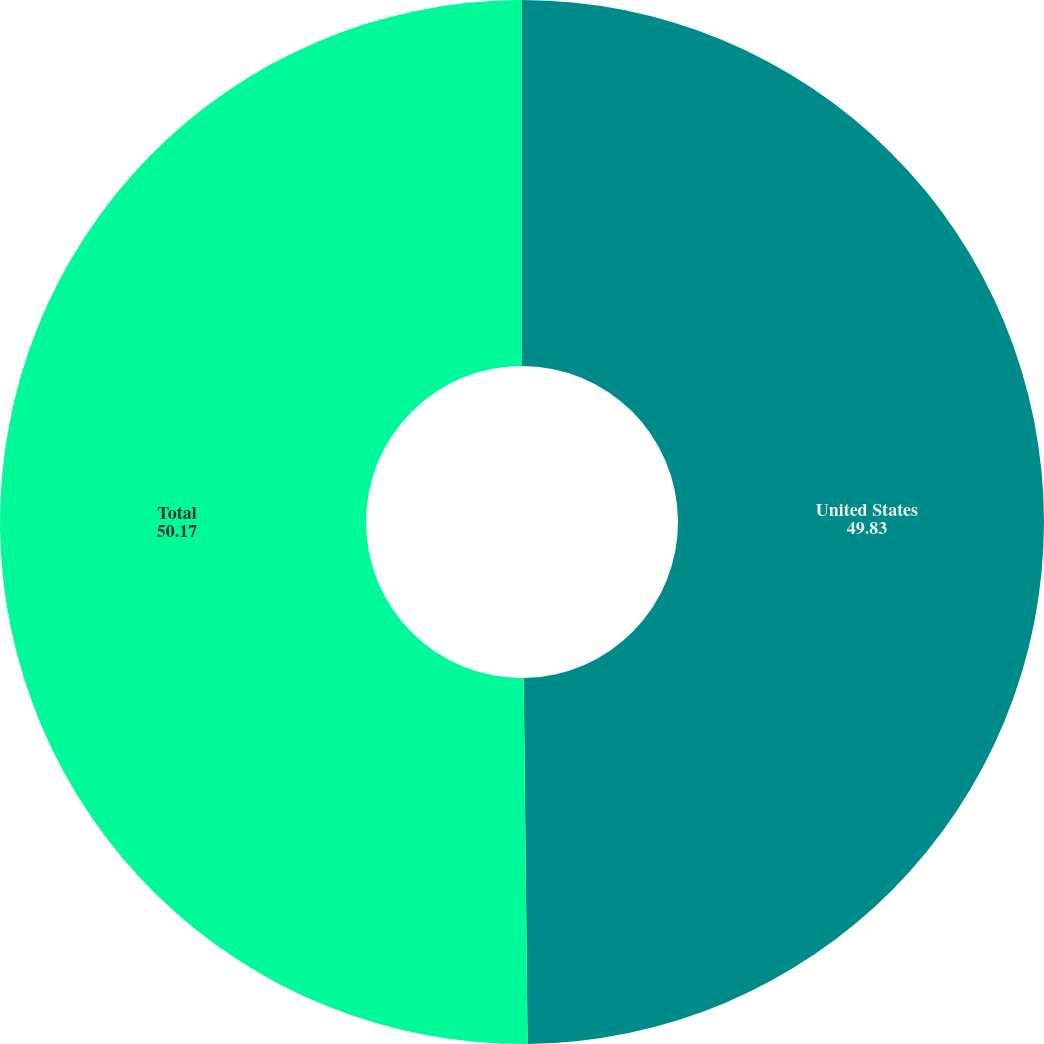Convert chart. <chart><loc_0><loc_0><loc_500><loc_500><pie_chart><fcel>United States<fcel>Total<nl><fcel>49.83%<fcel>50.17%<nl></chart> 